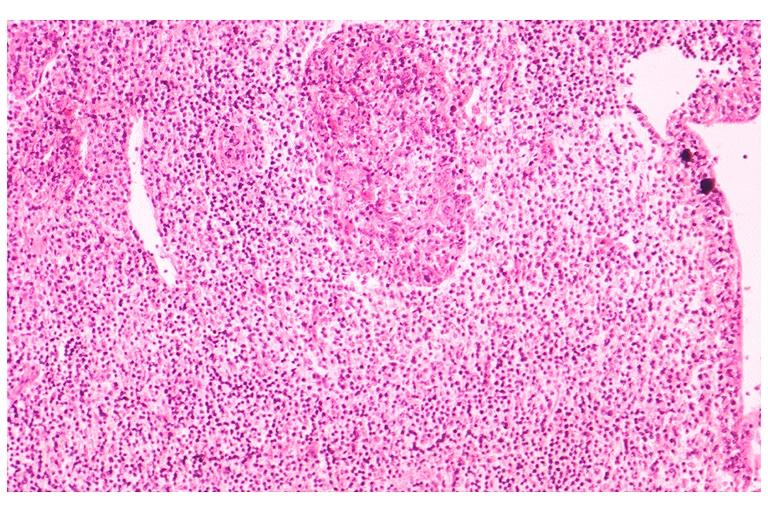does inflamed exocervix show sjogrens syndrome?
Answer the question using a single word or phrase. No 